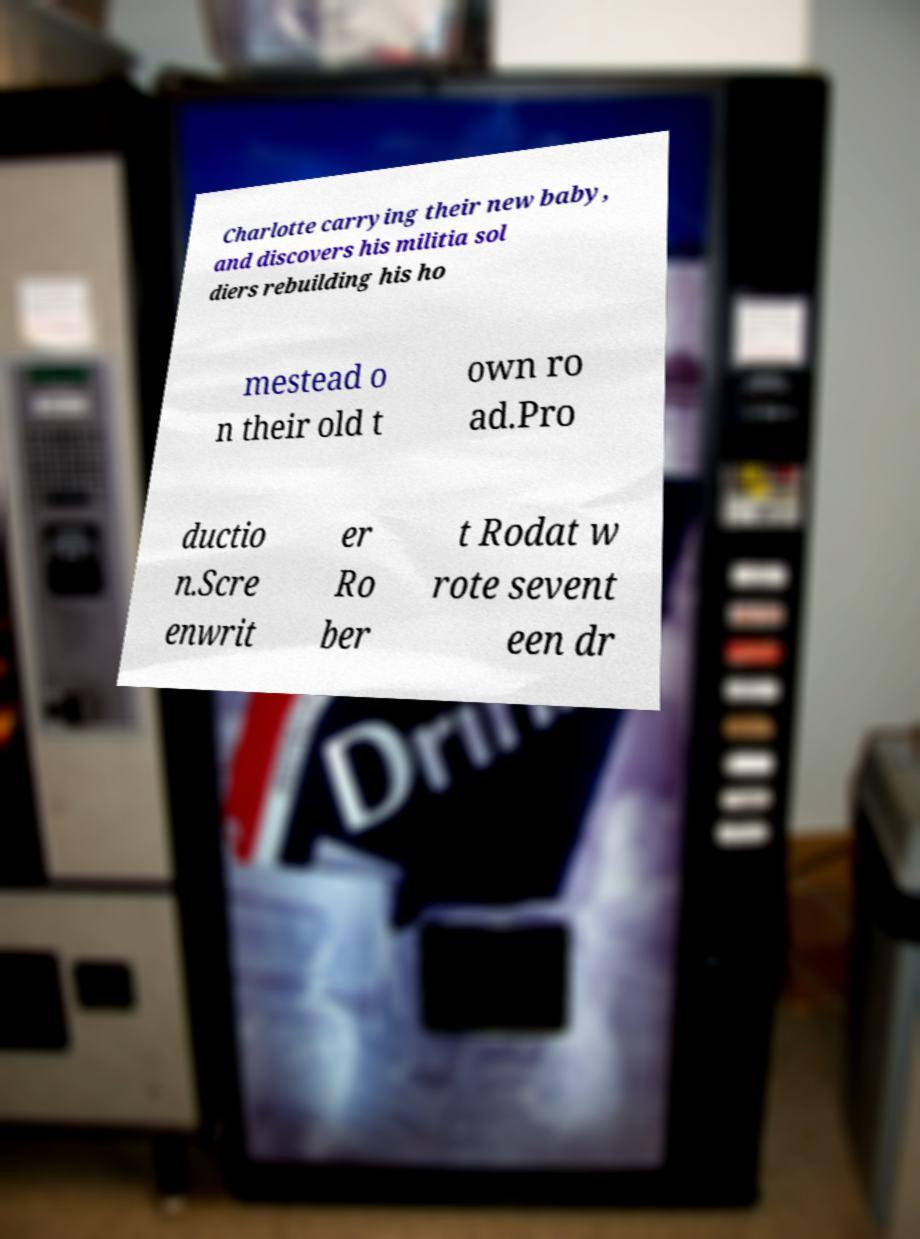For documentation purposes, I need the text within this image transcribed. Could you provide that? Charlotte carrying their new baby, and discovers his militia sol diers rebuilding his ho mestead o n their old t own ro ad.Pro ductio n.Scre enwrit er Ro ber t Rodat w rote sevent een dr 